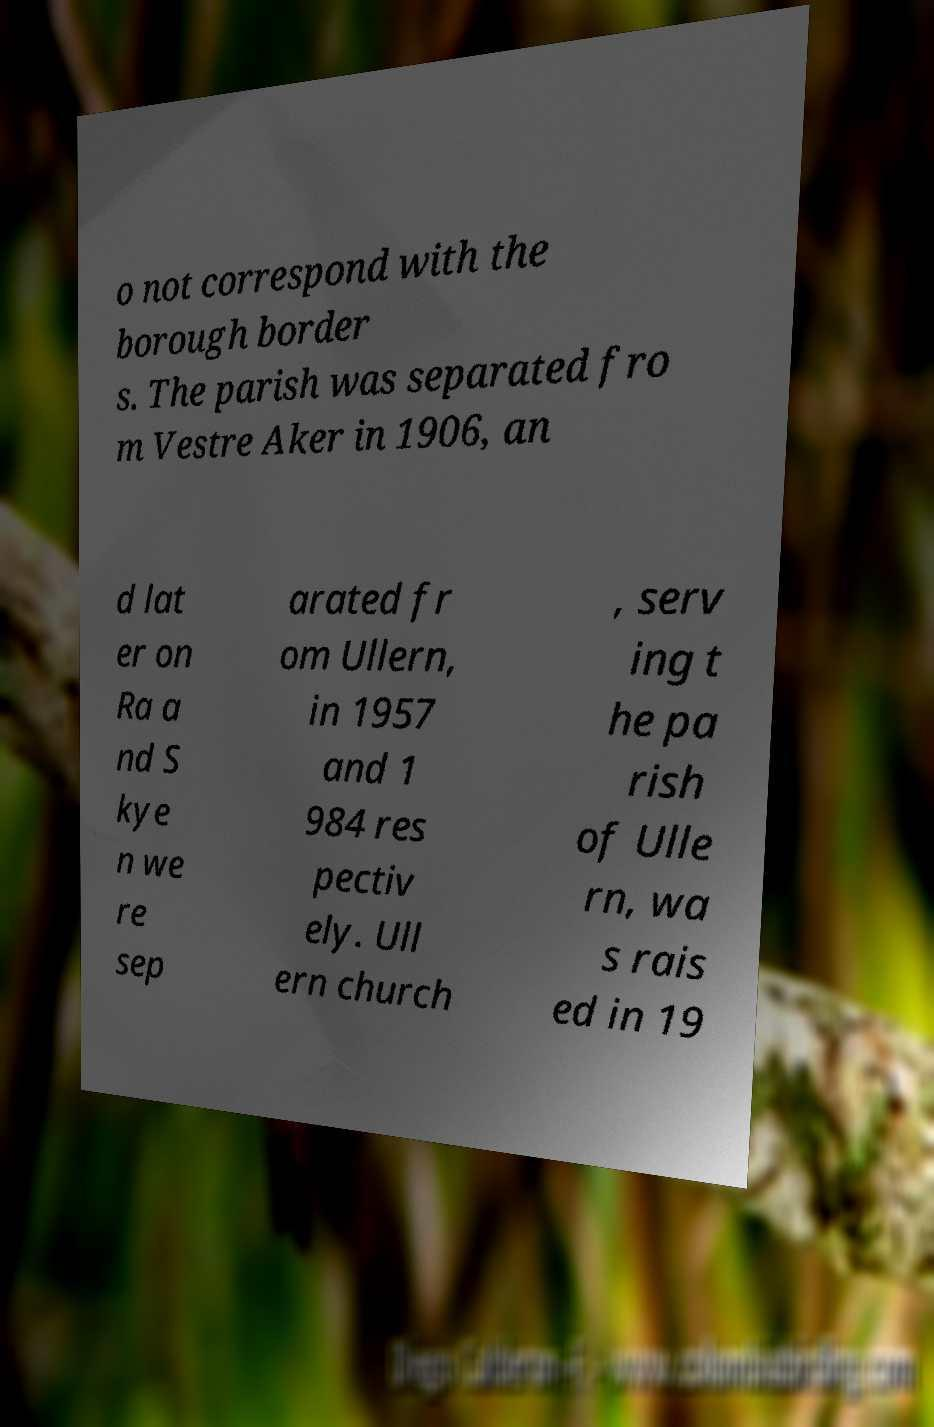There's text embedded in this image that I need extracted. Can you transcribe it verbatim? o not correspond with the borough border s. The parish was separated fro m Vestre Aker in 1906, an d lat er on Ra a nd S kye n we re sep arated fr om Ullern, in 1957 and 1 984 res pectiv ely. Ull ern church , serv ing t he pa rish of Ulle rn, wa s rais ed in 19 